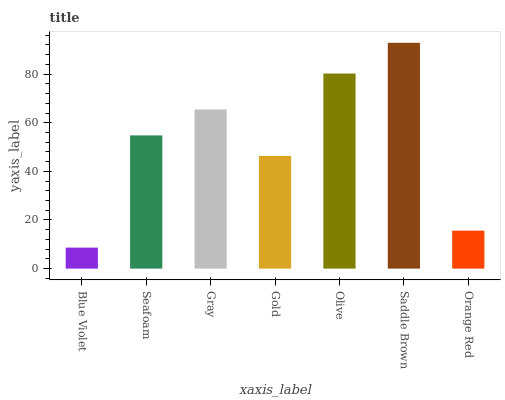Is Blue Violet the minimum?
Answer yes or no. Yes. Is Saddle Brown the maximum?
Answer yes or no. Yes. Is Seafoam the minimum?
Answer yes or no. No. Is Seafoam the maximum?
Answer yes or no. No. Is Seafoam greater than Blue Violet?
Answer yes or no. Yes. Is Blue Violet less than Seafoam?
Answer yes or no. Yes. Is Blue Violet greater than Seafoam?
Answer yes or no. No. Is Seafoam less than Blue Violet?
Answer yes or no. No. Is Seafoam the high median?
Answer yes or no. Yes. Is Seafoam the low median?
Answer yes or no. Yes. Is Orange Red the high median?
Answer yes or no. No. Is Gold the low median?
Answer yes or no. No. 